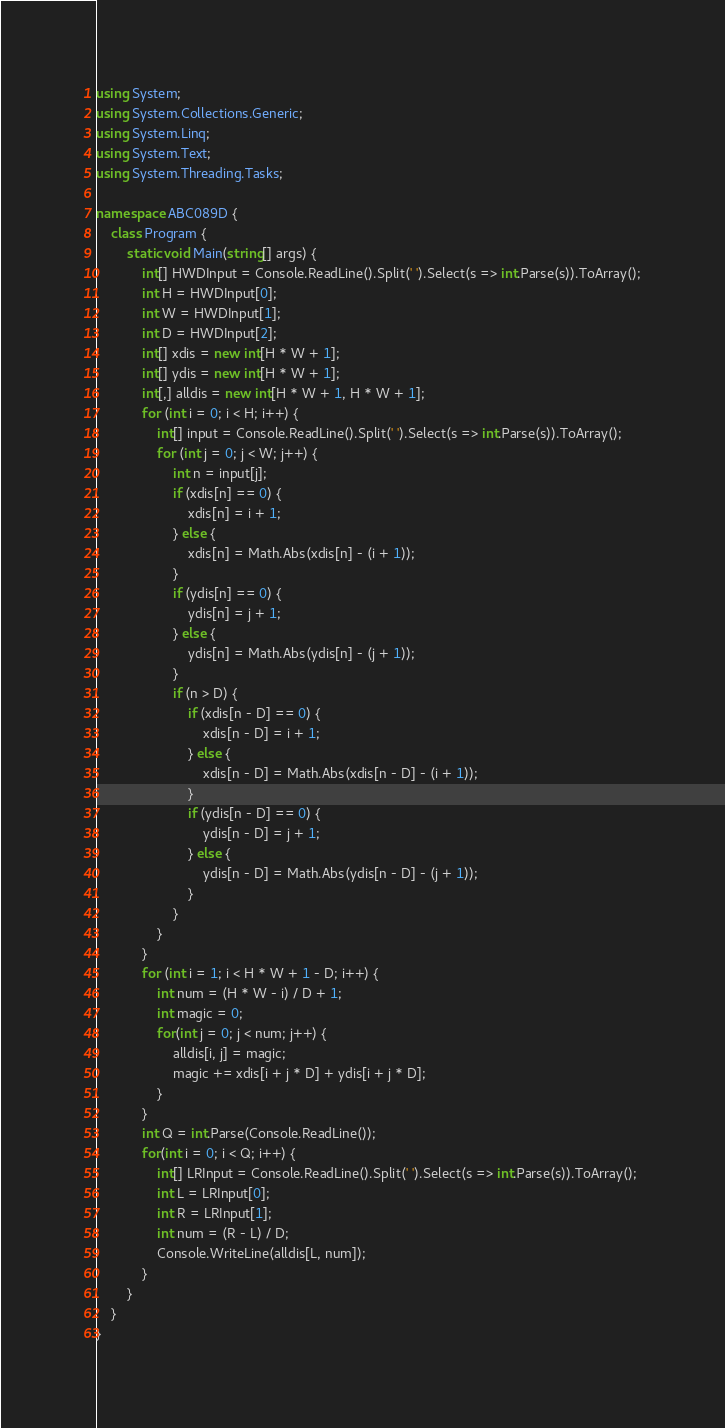Convert code to text. <code><loc_0><loc_0><loc_500><loc_500><_C#_>using System;
using System.Collections.Generic;
using System.Linq;
using System.Text;
using System.Threading.Tasks;

namespace ABC089D {
    class Program {
        static void Main(string[] args) {
            int[] HWDInput = Console.ReadLine().Split(' ').Select(s => int.Parse(s)).ToArray();
            int H = HWDInput[0];
            int W = HWDInput[1];
            int D = HWDInput[2];
            int[] xdis = new int[H * W + 1];
            int[] ydis = new int[H * W + 1];
            int[,] alldis = new int[H * W + 1, H * W + 1];
            for (int i = 0; i < H; i++) {
                int[] input = Console.ReadLine().Split(' ').Select(s => int.Parse(s)).ToArray();
                for (int j = 0; j < W; j++) {
                    int n = input[j];
                    if (xdis[n] == 0) {
                        xdis[n] = i + 1;
                    } else {
                        xdis[n] = Math.Abs(xdis[n] - (i + 1));
                    }
                    if (ydis[n] == 0) {
                        ydis[n] = j + 1;
                    } else {
                        ydis[n] = Math.Abs(ydis[n] - (j + 1));
                    }
                    if (n > D) {
                        if (xdis[n - D] == 0) {
                            xdis[n - D] = i + 1;
                        } else {
                            xdis[n - D] = Math.Abs(xdis[n - D] - (i + 1));
                        }
                        if (ydis[n - D] == 0) {
                            ydis[n - D] = j + 1;
                        } else {
                            ydis[n - D] = Math.Abs(ydis[n - D] - (j + 1));
                        }
                    }
                }
            }
            for (int i = 1; i < H * W + 1 - D; i++) {
                int num = (H * W - i) / D + 1;
                int magic = 0;
                for(int j = 0; j < num; j++) {
                    alldis[i, j] = magic;
                    magic += xdis[i + j * D] + ydis[i + j * D];
                }
            }
            int Q = int.Parse(Console.ReadLine());
            for(int i = 0; i < Q; i++) {
                int[] LRInput = Console.ReadLine().Split(' ').Select(s => int.Parse(s)).ToArray();
                int L = LRInput[0];
                int R = LRInput[1];
                int num = (R - L) / D;
                Console.WriteLine(alldis[L, num]);
            }
        }
    }
}
</code> 